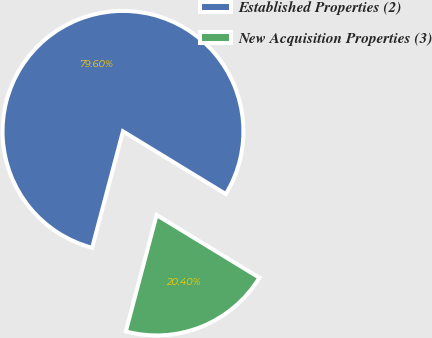Convert chart to OTSL. <chart><loc_0><loc_0><loc_500><loc_500><pie_chart><fcel>Established Properties (2)<fcel>New Acquisition Properties (3)<nl><fcel>79.6%<fcel>20.4%<nl></chart> 